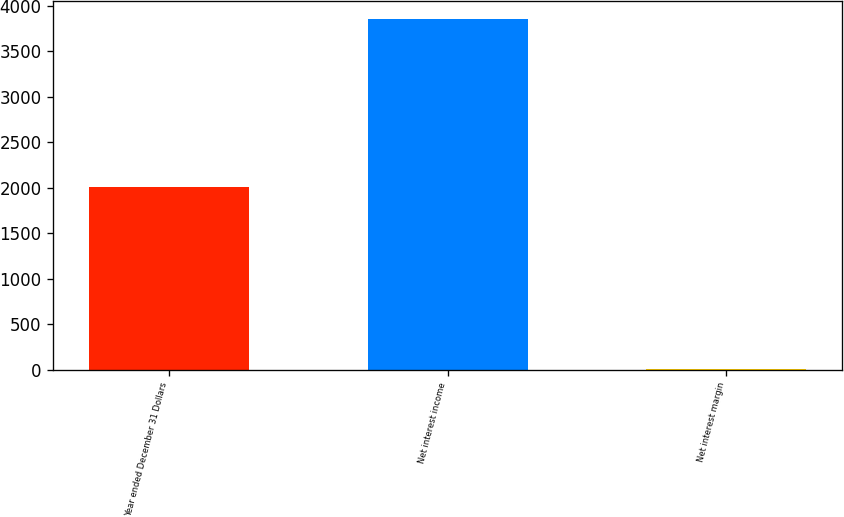<chart> <loc_0><loc_0><loc_500><loc_500><bar_chart><fcel>Year ended December 31 Dollars<fcel>Net interest income<fcel>Net interest margin<nl><fcel>2008<fcel>3854<fcel>3.37<nl></chart> 